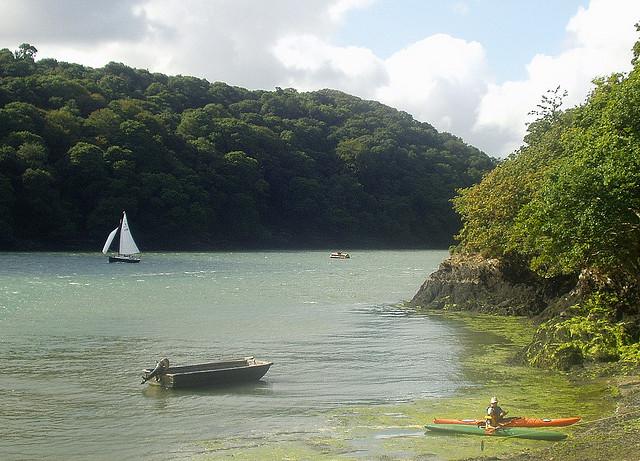Is anyone piloting the motor boat?
Answer briefly. No. How many boats are there?
Answer briefly. 4. How many sailboats are there?
Give a very brief answer. 1. Where is the kayak?
Be succinct. Shore. 